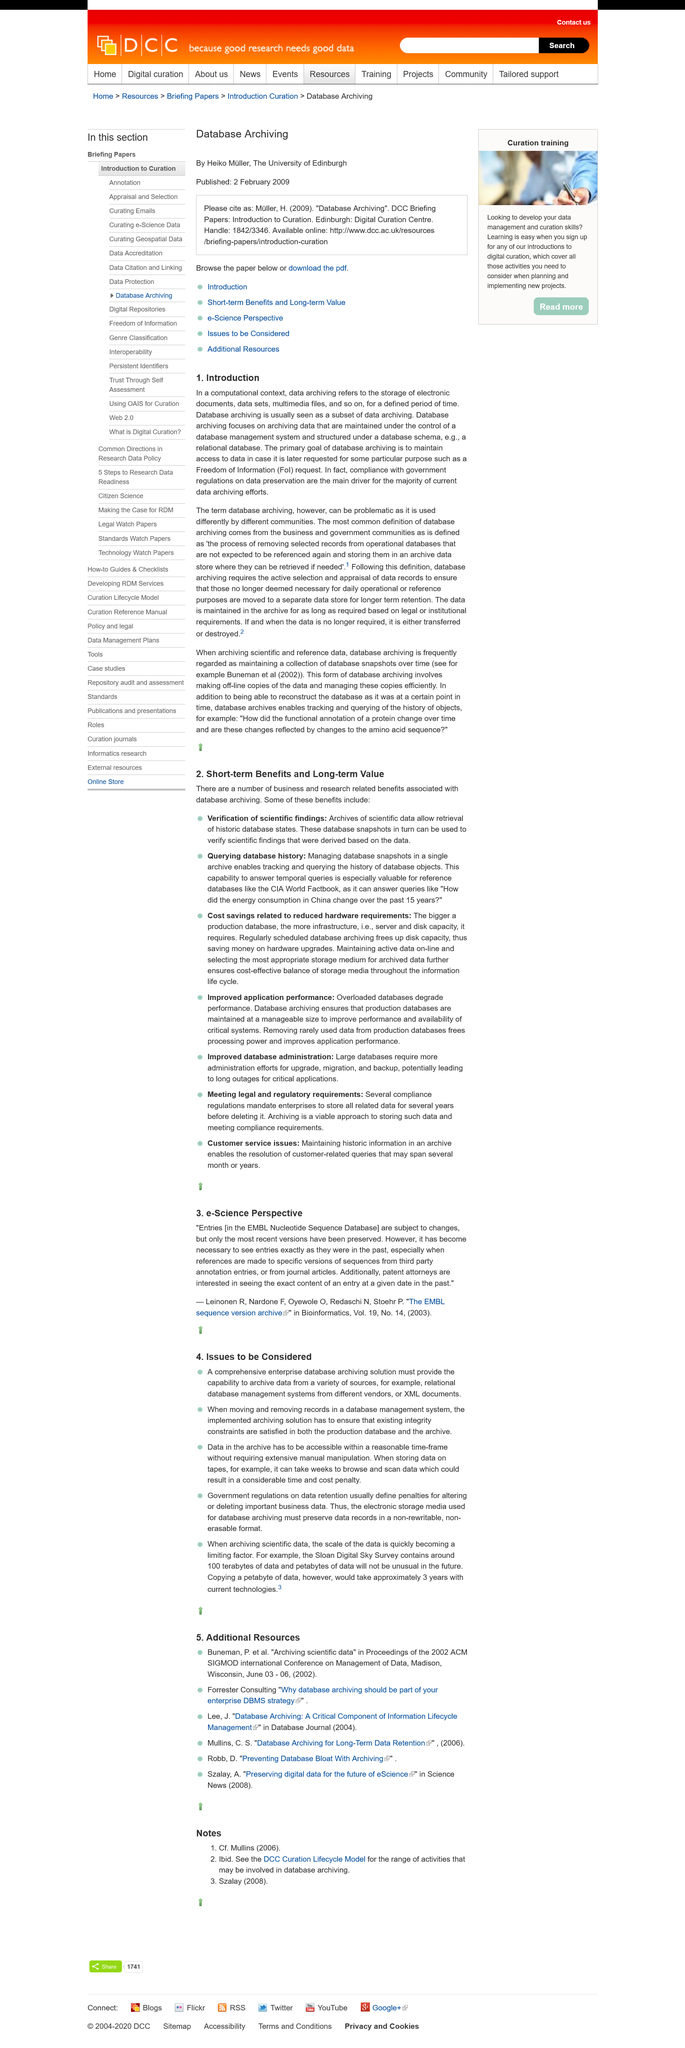Identify some key points in this picture. This piece is referring to a computational context. This article introduces the concept of database archiving in the context of computational processes. The title of the subheading is "Introduction". 